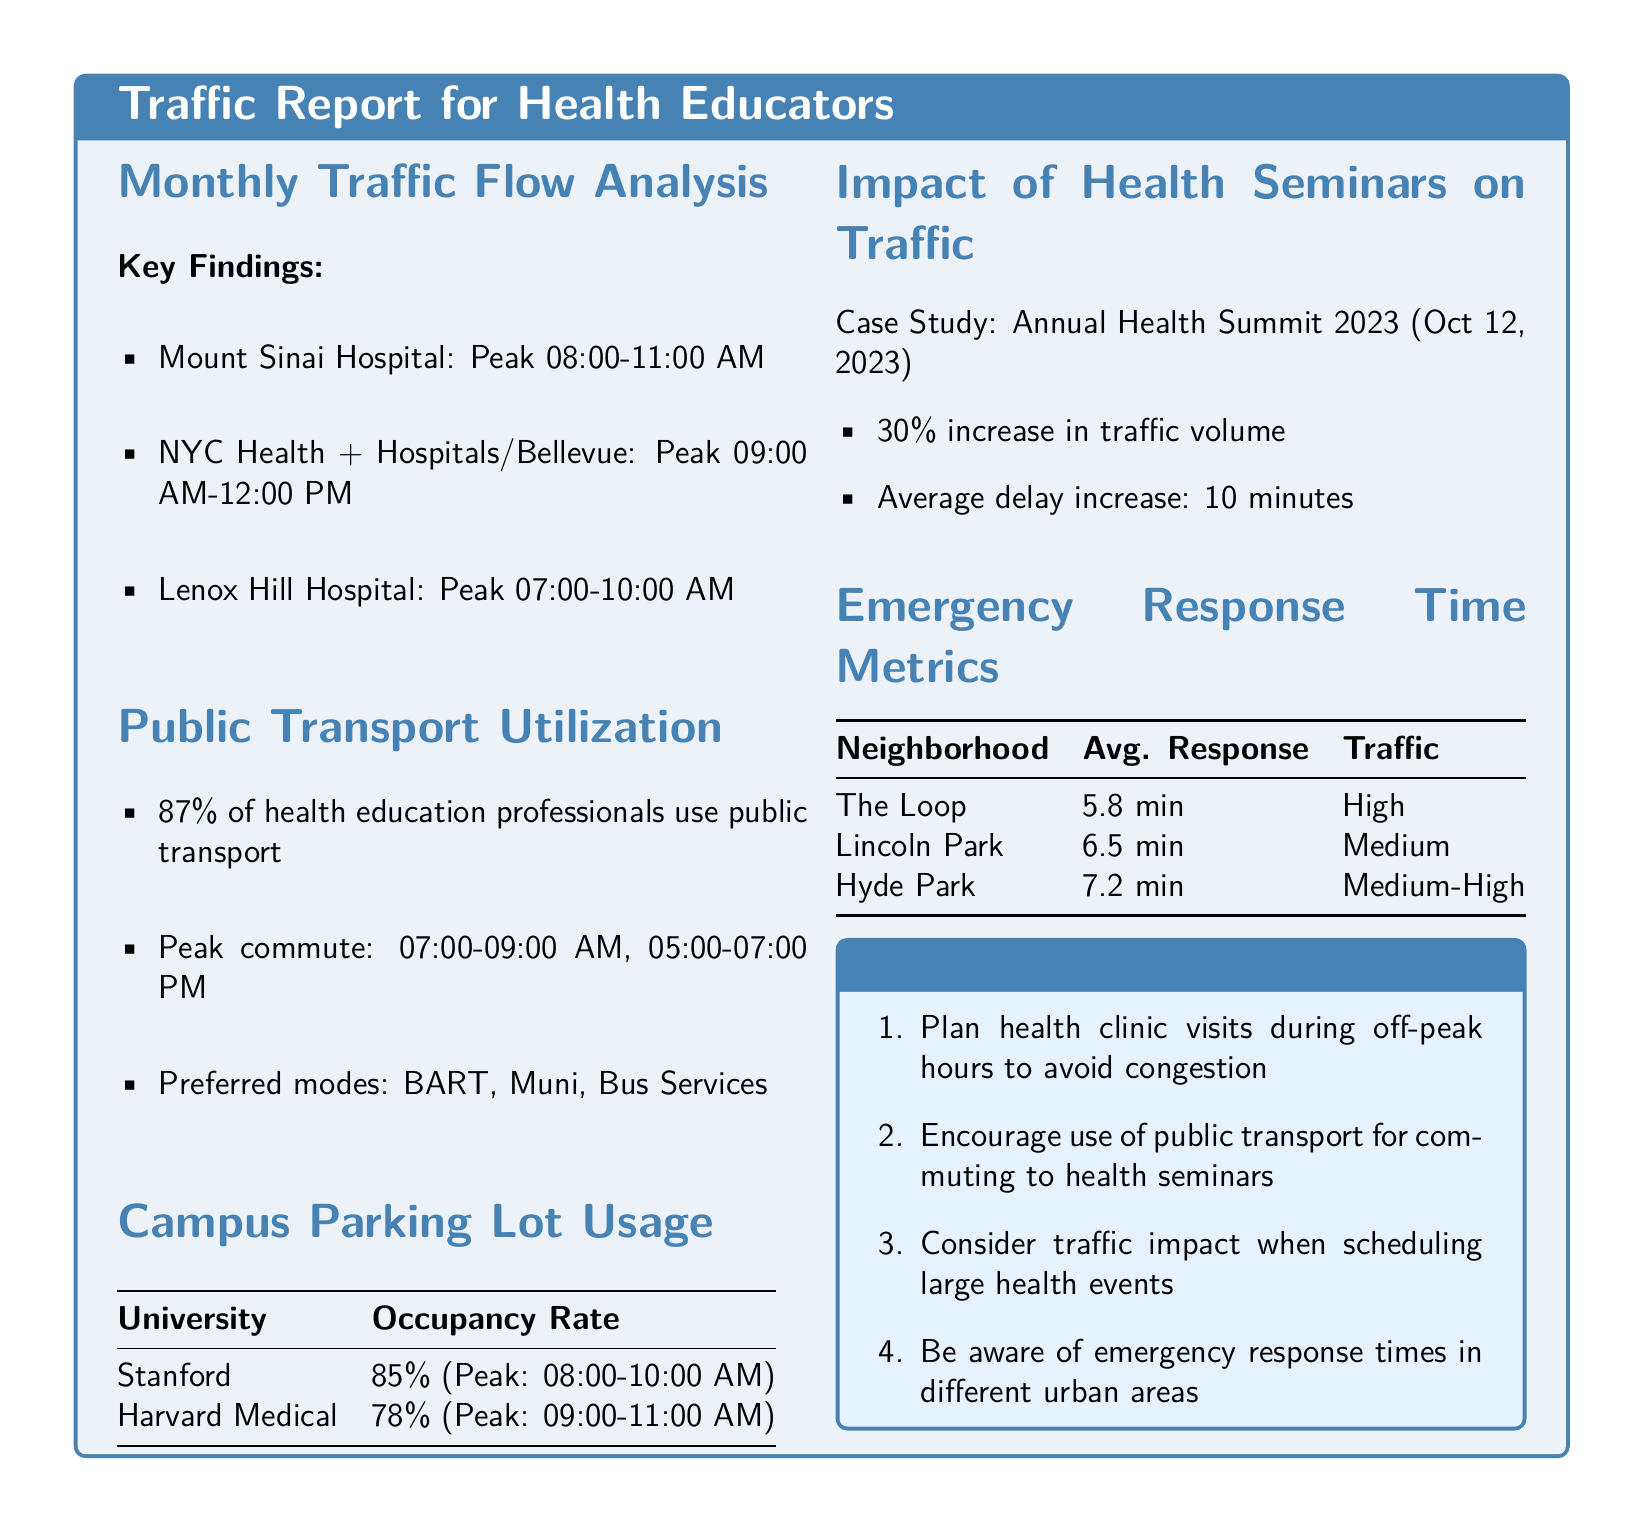What is the peak hour for Mount Sinai Hospital? The peak hour for Mount Sinai Hospital is provided in the Monthly Traffic Flow Analysis section of the document.
Answer: 08:00-11:00 AM What percentage of health education professionals use public transport? The percentage is indicated in the Public Transport Utilization section.
Answer: 87% What is the occupancy rate at Stanford University during peak times? The occupancy rate is listed in the Campus Parking Lot Usage section.
Answer: 85% What was the average delay increase during the Annual Health Summit 2023? The average delay increase is mentioned in the Impact of Health Seminars on Traffic section.
Answer: 10 minutes What is the average response time in The Loop neighborhood? The average response time is found in the Emergency Response Time Metrics section.
Answer: 5.8 min What is the preferred mode of transport by health education professionals? The preferred mode of transport is detailed in the Public Transport Utilization section.
Answer: BART, Muni, Bus Services Which university has a parking lot occupancy peak from 09:00-11:00 AM? The university with this peak time is specified in the Campus Parking Lot Usage section.
Answer: Harvard Medical How much did traffic volume increase during the Annual Health Summit 2023? The document specifies how much traffic volume increased in the case study section.
Answer: 30% What traffic density classification does Lincoln Park fall under? The classification appears in the Emergency Response Time Metrics section.
Answer: Medium 